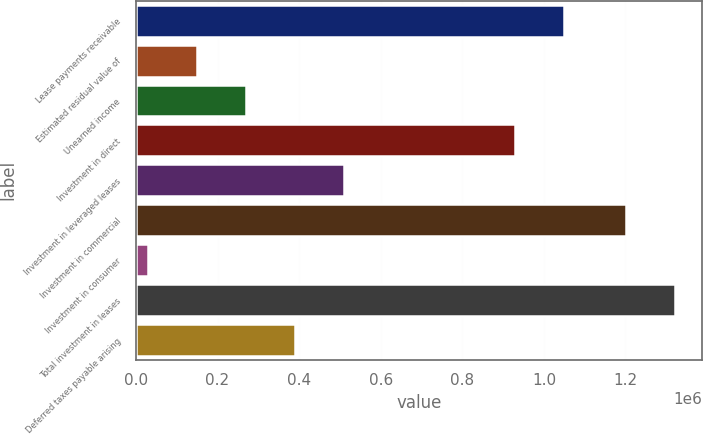Convert chart to OTSL. <chart><loc_0><loc_0><loc_500><loc_500><bar_chart><fcel>Lease payments receivable<fcel>Estimated residual value of<fcel>Unearned income<fcel>Investment in direct<fcel>Investment in leveraged leases<fcel>Investment in commercial<fcel>Investment in consumer<fcel>Total investment in leases<fcel>Deferred taxes payable arising<nl><fcel>1.04878e+06<fcel>149513<fcel>269613<fcel>928683<fcel>509814<fcel>1.201e+06<fcel>29413<fcel>1.3211e+06<fcel>389714<nl></chart> 